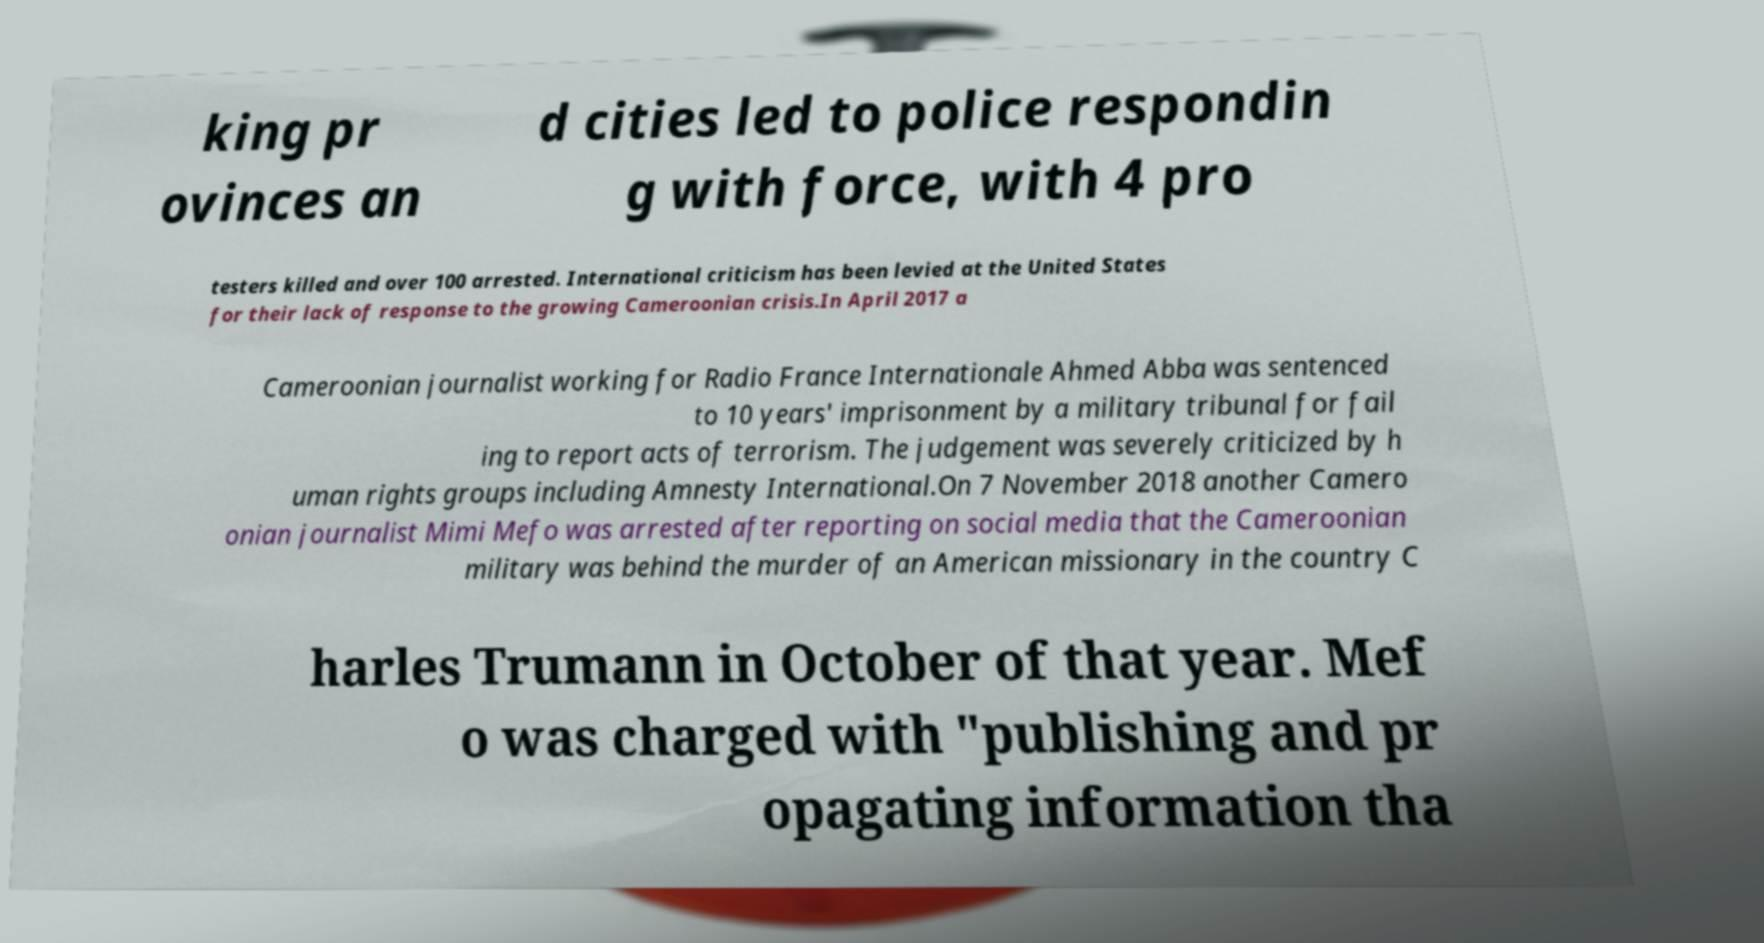Could you assist in decoding the text presented in this image and type it out clearly? king pr ovinces an d cities led to police respondin g with force, with 4 pro testers killed and over 100 arrested. International criticism has been levied at the United States for their lack of response to the growing Cameroonian crisis.In April 2017 a Cameroonian journalist working for Radio France Internationale Ahmed Abba was sentenced to 10 years' imprisonment by a military tribunal for fail ing to report acts of terrorism. The judgement was severely criticized by h uman rights groups including Amnesty International.On 7 November 2018 another Camero onian journalist Mimi Mefo was arrested after reporting on social media that the Cameroonian military was behind the murder of an American missionary in the country C harles Trumann in October of that year. Mef o was charged with "publishing and pr opagating information tha 